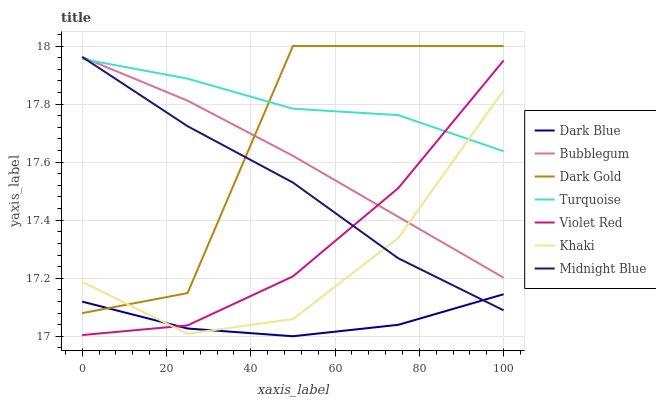Does Dark Blue have the minimum area under the curve?
Answer yes or no. Yes. Does Turquoise have the maximum area under the curve?
Answer yes or no. Yes. Does Khaki have the minimum area under the curve?
Answer yes or no. No. Does Khaki have the maximum area under the curve?
Answer yes or no. No. Is Bubblegum the smoothest?
Answer yes or no. Yes. Is Dark Gold the roughest?
Answer yes or no. Yes. Is Khaki the smoothest?
Answer yes or no. No. Is Khaki the roughest?
Answer yes or no. No. Does Dark Blue have the lowest value?
Answer yes or no. Yes. Does Khaki have the lowest value?
Answer yes or no. No. Does Dark Gold have the highest value?
Answer yes or no. Yes. Does Khaki have the highest value?
Answer yes or no. No. Is Dark Blue less than Turquoise?
Answer yes or no. Yes. Is Bubblegum greater than Dark Blue?
Answer yes or no. Yes. Does Bubblegum intersect Dark Gold?
Answer yes or no. Yes. Is Bubblegum less than Dark Gold?
Answer yes or no. No. Is Bubblegum greater than Dark Gold?
Answer yes or no. No. Does Dark Blue intersect Turquoise?
Answer yes or no. No. 